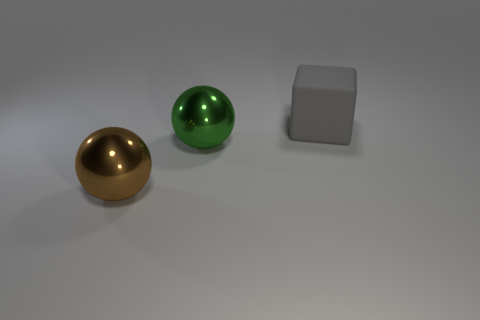Add 3 large gray rubber objects. How many objects exist? 6 Subtract all balls. How many objects are left? 1 Subtract all green spheres. How many spheres are left? 1 Subtract 0 green cylinders. How many objects are left? 3 Subtract 1 balls. How many balls are left? 1 Subtract all red balls. Subtract all purple blocks. How many balls are left? 2 Subtract all green cylinders. How many brown balls are left? 1 Subtract all big green spheres. Subtract all large cyan rubber cubes. How many objects are left? 2 Add 1 big brown spheres. How many big brown spheres are left? 2 Add 3 metal objects. How many metal objects exist? 5 